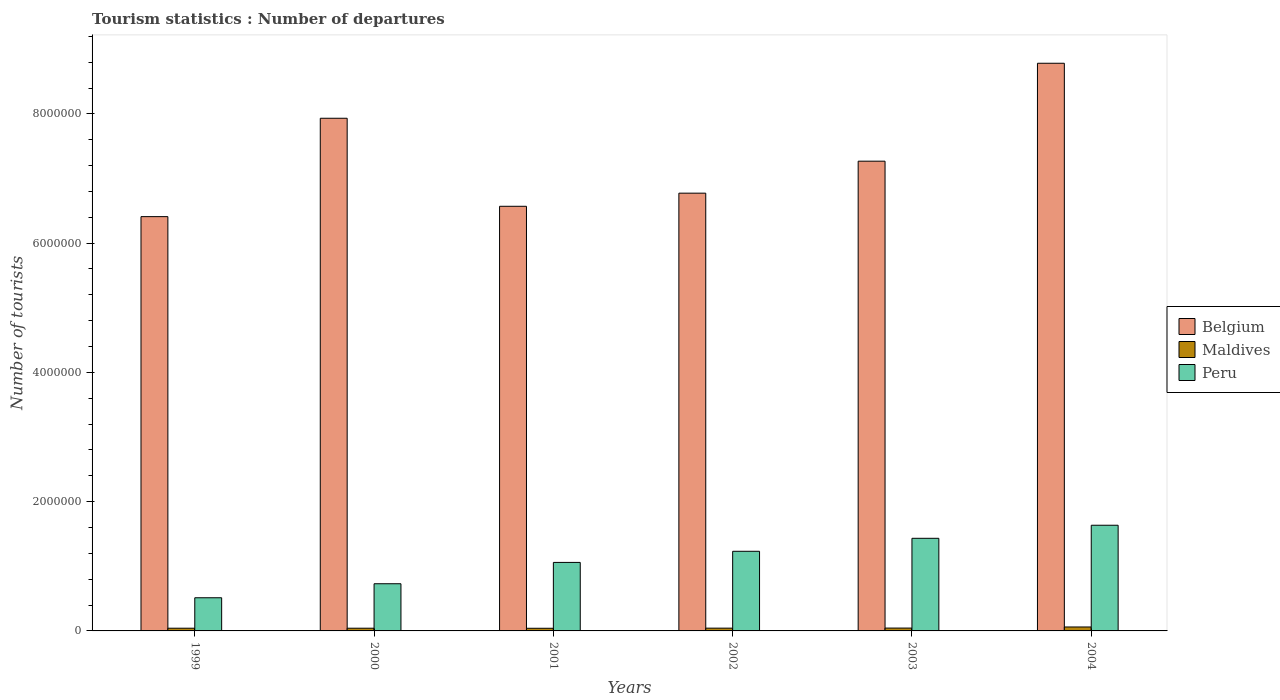Are the number of bars per tick equal to the number of legend labels?
Offer a very short reply. Yes. Are the number of bars on each tick of the X-axis equal?
Offer a terse response. Yes. How many bars are there on the 2nd tick from the right?
Offer a terse response. 3. What is the label of the 6th group of bars from the left?
Keep it short and to the point. 2004. What is the number of tourist departures in Maldives in 1999?
Your answer should be compact. 4.20e+04. Across all years, what is the maximum number of tourist departures in Belgium?
Your answer should be compact. 8.78e+06. Across all years, what is the minimum number of tourist departures in Maldives?
Keep it short and to the point. 4.10e+04. In which year was the number of tourist departures in Belgium minimum?
Provide a short and direct response. 1999. What is the total number of tourist departures in Belgium in the graph?
Provide a succinct answer. 4.37e+07. What is the difference between the number of tourist departures in Peru in 2000 and that in 2003?
Give a very brief answer. -7.03e+05. What is the difference between the number of tourist departures in Peru in 1999 and the number of tourist departures in Belgium in 2004?
Ensure brevity in your answer.  -8.27e+06. What is the average number of tourist departures in Belgium per year?
Offer a terse response. 7.29e+06. In the year 2004, what is the difference between the number of tourist departures in Maldives and number of tourist departures in Belgium?
Offer a very short reply. -8.72e+06. What is the ratio of the number of tourist departures in Belgium in 2001 to that in 2002?
Provide a short and direct response. 0.97. Is the number of tourist departures in Belgium in 1999 less than that in 2000?
Give a very brief answer. Yes. What is the difference between the highest and the second highest number of tourist departures in Peru?
Make the answer very short. 2.02e+05. What is the difference between the highest and the lowest number of tourist departures in Belgium?
Offer a very short reply. 2.37e+06. In how many years, is the number of tourist departures in Peru greater than the average number of tourist departures in Peru taken over all years?
Your response must be concise. 3. What does the 2nd bar from the left in 2002 represents?
Give a very brief answer. Maldives. Is it the case that in every year, the sum of the number of tourist departures in Peru and number of tourist departures in Maldives is greater than the number of tourist departures in Belgium?
Keep it short and to the point. No. How many bars are there?
Offer a very short reply. 18. What is the difference between two consecutive major ticks on the Y-axis?
Provide a succinct answer. 2.00e+06. Are the values on the major ticks of Y-axis written in scientific E-notation?
Your response must be concise. No. Does the graph contain any zero values?
Give a very brief answer. No. Does the graph contain grids?
Ensure brevity in your answer.  No. How are the legend labels stacked?
Make the answer very short. Vertical. What is the title of the graph?
Make the answer very short. Tourism statistics : Number of departures. What is the label or title of the Y-axis?
Ensure brevity in your answer.  Number of tourists. What is the Number of tourists of Belgium in 1999?
Make the answer very short. 6.41e+06. What is the Number of tourists in Maldives in 1999?
Provide a succinct answer. 4.20e+04. What is the Number of tourists of Peru in 1999?
Your answer should be compact. 5.13e+05. What is the Number of tourists in Belgium in 2000?
Offer a terse response. 7.93e+06. What is the Number of tourists of Maldives in 2000?
Ensure brevity in your answer.  4.20e+04. What is the Number of tourists in Peru in 2000?
Provide a short and direct response. 7.30e+05. What is the Number of tourists of Belgium in 2001?
Offer a terse response. 6.57e+06. What is the Number of tourists of Maldives in 2001?
Your answer should be compact. 4.10e+04. What is the Number of tourists in Peru in 2001?
Offer a very short reply. 1.06e+06. What is the Number of tourists in Belgium in 2002?
Make the answer very short. 6.77e+06. What is the Number of tourists in Maldives in 2002?
Your response must be concise. 4.30e+04. What is the Number of tourists of Peru in 2002?
Provide a short and direct response. 1.23e+06. What is the Number of tourists of Belgium in 2003?
Your response must be concise. 7.27e+06. What is the Number of tourists of Maldives in 2003?
Give a very brief answer. 4.40e+04. What is the Number of tourists in Peru in 2003?
Your response must be concise. 1.43e+06. What is the Number of tourists of Belgium in 2004?
Your answer should be compact. 8.78e+06. What is the Number of tourists in Maldives in 2004?
Give a very brief answer. 6.10e+04. What is the Number of tourists of Peru in 2004?
Offer a very short reply. 1.64e+06. Across all years, what is the maximum Number of tourists in Belgium?
Provide a succinct answer. 8.78e+06. Across all years, what is the maximum Number of tourists of Maldives?
Your answer should be very brief. 6.10e+04. Across all years, what is the maximum Number of tourists in Peru?
Your response must be concise. 1.64e+06. Across all years, what is the minimum Number of tourists in Belgium?
Ensure brevity in your answer.  6.41e+06. Across all years, what is the minimum Number of tourists of Maldives?
Your answer should be compact. 4.10e+04. Across all years, what is the minimum Number of tourists of Peru?
Offer a terse response. 5.13e+05. What is the total Number of tourists in Belgium in the graph?
Make the answer very short. 4.37e+07. What is the total Number of tourists in Maldives in the graph?
Offer a terse response. 2.73e+05. What is the total Number of tourists of Peru in the graph?
Your answer should be very brief. 6.60e+06. What is the difference between the Number of tourists in Belgium in 1999 and that in 2000?
Offer a very short reply. -1.52e+06. What is the difference between the Number of tourists in Maldives in 1999 and that in 2000?
Provide a succinct answer. 0. What is the difference between the Number of tourists in Peru in 1999 and that in 2000?
Your answer should be compact. -2.17e+05. What is the difference between the Number of tourists of Maldives in 1999 and that in 2001?
Your answer should be compact. 1000. What is the difference between the Number of tourists in Peru in 1999 and that in 2001?
Make the answer very short. -5.47e+05. What is the difference between the Number of tourists in Belgium in 1999 and that in 2002?
Offer a terse response. -3.63e+05. What is the difference between the Number of tourists in Maldives in 1999 and that in 2002?
Keep it short and to the point. -1000. What is the difference between the Number of tourists in Peru in 1999 and that in 2002?
Provide a short and direct response. -7.19e+05. What is the difference between the Number of tourists in Belgium in 1999 and that in 2003?
Your answer should be very brief. -8.58e+05. What is the difference between the Number of tourists in Maldives in 1999 and that in 2003?
Provide a short and direct response. -2000. What is the difference between the Number of tourists in Peru in 1999 and that in 2003?
Ensure brevity in your answer.  -9.20e+05. What is the difference between the Number of tourists in Belgium in 1999 and that in 2004?
Offer a terse response. -2.37e+06. What is the difference between the Number of tourists in Maldives in 1999 and that in 2004?
Your answer should be very brief. -1.90e+04. What is the difference between the Number of tourists of Peru in 1999 and that in 2004?
Make the answer very short. -1.12e+06. What is the difference between the Number of tourists in Belgium in 2000 and that in 2001?
Give a very brief answer. 1.36e+06. What is the difference between the Number of tourists in Maldives in 2000 and that in 2001?
Provide a short and direct response. 1000. What is the difference between the Number of tourists of Peru in 2000 and that in 2001?
Keep it short and to the point. -3.30e+05. What is the difference between the Number of tourists of Belgium in 2000 and that in 2002?
Offer a very short reply. 1.16e+06. What is the difference between the Number of tourists of Maldives in 2000 and that in 2002?
Provide a succinct answer. -1000. What is the difference between the Number of tourists in Peru in 2000 and that in 2002?
Keep it short and to the point. -5.02e+05. What is the difference between the Number of tourists in Belgium in 2000 and that in 2003?
Offer a very short reply. 6.64e+05. What is the difference between the Number of tourists of Maldives in 2000 and that in 2003?
Offer a very short reply. -2000. What is the difference between the Number of tourists in Peru in 2000 and that in 2003?
Your response must be concise. -7.03e+05. What is the difference between the Number of tourists in Belgium in 2000 and that in 2004?
Make the answer very short. -8.51e+05. What is the difference between the Number of tourists in Maldives in 2000 and that in 2004?
Offer a terse response. -1.90e+04. What is the difference between the Number of tourists in Peru in 2000 and that in 2004?
Offer a terse response. -9.05e+05. What is the difference between the Number of tourists of Belgium in 2001 and that in 2002?
Ensure brevity in your answer.  -2.03e+05. What is the difference between the Number of tourists of Maldives in 2001 and that in 2002?
Offer a very short reply. -2000. What is the difference between the Number of tourists of Peru in 2001 and that in 2002?
Your answer should be compact. -1.72e+05. What is the difference between the Number of tourists of Belgium in 2001 and that in 2003?
Your answer should be compact. -6.98e+05. What is the difference between the Number of tourists in Maldives in 2001 and that in 2003?
Give a very brief answer. -3000. What is the difference between the Number of tourists of Peru in 2001 and that in 2003?
Your answer should be very brief. -3.73e+05. What is the difference between the Number of tourists of Belgium in 2001 and that in 2004?
Provide a succinct answer. -2.21e+06. What is the difference between the Number of tourists of Peru in 2001 and that in 2004?
Keep it short and to the point. -5.75e+05. What is the difference between the Number of tourists of Belgium in 2002 and that in 2003?
Your response must be concise. -4.95e+05. What is the difference between the Number of tourists of Maldives in 2002 and that in 2003?
Your response must be concise. -1000. What is the difference between the Number of tourists in Peru in 2002 and that in 2003?
Ensure brevity in your answer.  -2.01e+05. What is the difference between the Number of tourists in Belgium in 2002 and that in 2004?
Provide a short and direct response. -2.01e+06. What is the difference between the Number of tourists in Maldives in 2002 and that in 2004?
Your response must be concise. -1.80e+04. What is the difference between the Number of tourists of Peru in 2002 and that in 2004?
Provide a succinct answer. -4.03e+05. What is the difference between the Number of tourists of Belgium in 2003 and that in 2004?
Offer a very short reply. -1.52e+06. What is the difference between the Number of tourists of Maldives in 2003 and that in 2004?
Keep it short and to the point. -1.70e+04. What is the difference between the Number of tourists in Peru in 2003 and that in 2004?
Keep it short and to the point. -2.02e+05. What is the difference between the Number of tourists of Belgium in 1999 and the Number of tourists of Maldives in 2000?
Ensure brevity in your answer.  6.37e+06. What is the difference between the Number of tourists of Belgium in 1999 and the Number of tourists of Peru in 2000?
Ensure brevity in your answer.  5.68e+06. What is the difference between the Number of tourists of Maldives in 1999 and the Number of tourists of Peru in 2000?
Your response must be concise. -6.88e+05. What is the difference between the Number of tourists of Belgium in 1999 and the Number of tourists of Maldives in 2001?
Your answer should be compact. 6.37e+06. What is the difference between the Number of tourists in Belgium in 1999 and the Number of tourists in Peru in 2001?
Ensure brevity in your answer.  5.35e+06. What is the difference between the Number of tourists in Maldives in 1999 and the Number of tourists in Peru in 2001?
Provide a short and direct response. -1.02e+06. What is the difference between the Number of tourists of Belgium in 1999 and the Number of tourists of Maldives in 2002?
Make the answer very short. 6.37e+06. What is the difference between the Number of tourists of Belgium in 1999 and the Number of tourists of Peru in 2002?
Give a very brief answer. 5.18e+06. What is the difference between the Number of tourists in Maldives in 1999 and the Number of tourists in Peru in 2002?
Your answer should be very brief. -1.19e+06. What is the difference between the Number of tourists in Belgium in 1999 and the Number of tourists in Maldives in 2003?
Give a very brief answer. 6.37e+06. What is the difference between the Number of tourists of Belgium in 1999 and the Number of tourists of Peru in 2003?
Offer a very short reply. 4.98e+06. What is the difference between the Number of tourists in Maldives in 1999 and the Number of tourists in Peru in 2003?
Your answer should be very brief. -1.39e+06. What is the difference between the Number of tourists of Belgium in 1999 and the Number of tourists of Maldives in 2004?
Offer a very short reply. 6.35e+06. What is the difference between the Number of tourists in Belgium in 1999 and the Number of tourists in Peru in 2004?
Ensure brevity in your answer.  4.78e+06. What is the difference between the Number of tourists in Maldives in 1999 and the Number of tourists in Peru in 2004?
Ensure brevity in your answer.  -1.59e+06. What is the difference between the Number of tourists of Belgium in 2000 and the Number of tourists of Maldives in 2001?
Provide a short and direct response. 7.89e+06. What is the difference between the Number of tourists in Belgium in 2000 and the Number of tourists in Peru in 2001?
Your answer should be very brief. 6.87e+06. What is the difference between the Number of tourists of Maldives in 2000 and the Number of tourists of Peru in 2001?
Your response must be concise. -1.02e+06. What is the difference between the Number of tourists in Belgium in 2000 and the Number of tourists in Maldives in 2002?
Give a very brief answer. 7.89e+06. What is the difference between the Number of tourists in Belgium in 2000 and the Number of tourists in Peru in 2002?
Keep it short and to the point. 6.70e+06. What is the difference between the Number of tourists in Maldives in 2000 and the Number of tourists in Peru in 2002?
Make the answer very short. -1.19e+06. What is the difference between the Number of tourists of Belgium in 2000 and the Number of tourists of Maldives in 2003?
Your answer should be compact. 7.89e+06. What is the difference between the Number of tourists of Belgium in 2000 and the Number of tourists of Peru in 2003?
Ensure brevity in your answer.  6.50e+06. What is the difference between the Number of tourists of Maldives in 2000 and the Number of tourists of Peru in 2003?
Give a very brief answer. -1.39e+06. What is the difference between the Number of tourists of Belgium in 2000 and the Number of tourists of Maldives in 2004?
Ensure brevity in your answer.  7.87e+06. What is the difference between the Number of tourists of Belgium in 2000 and the Number of tourists of Peru in 2004?
Your answer should be very brief. 6.30e+06. What is the difference between the Number of tourists in Maldives in 2000 and the Number of tourists in Peru in 2004?
Your answer should be very brief. -1.59e+06. What is the difference between the Number of tourists of Belgium in 2001 and the Number of tourists of Maldives in 2002?
Make the answer very short. 6.53e+06. What is the difference between the Number of tourists in Belgium in 2001 and the Number of tourists in Peru in 2002?
Give a very brief answer. 5.34e+06. What is the difference between the Number of tourists of Maldives in 2001 and the Number of tourists of Peru in 2002?
Provide a short and direct response. -1.19e+06. What is the difference between the Number of tourists of Belgium in 2001 and the Number of tourists of Maldives in 2003?
Offer a terse response. 6.53e+06. What is the difference between the Number of tourists in Belgium in 2001 and the Number of tourists in Peru in 2003?
Offer a terse response. 5.14e+06. What is the difference between the Number of tourists of Maldives in 2001 and the Number of tourists of Peru in 2003?
Give a very brief answer. -1.39e+06. What is the difference between the Number of tourists in Belgium in 2001 and the Number of tourists in Maldives in 2004?
Ensure brevity in your answer.  6.51e+06. What is the difference between the Number of tourists of Belgium in 2001 and the Number of tourists of Peru in 2004?
Your answer should be compact. 4.94e+06. What is the difference between the Number of tourists of Maldives in 2001 and the Number of tourists of Peru in 2004?
Make the answer very short. -1.59e+06. What is the difference between the Number of tourists in Belgium in 2002 and the Number of tourists in Maldives in 2003?
Give a very brief answer. 6.73e+06. What is the difference between the Number of tourists of Belgium in 2002 and the Number of tourists of Peru in 2003?
Make the answer very short. 5.34e+06. What is the difference between the Number of tourists of Maldives in 2002 and the Number of tourists of Peru in 2003?
Ensure brevity in your answer.  -1.39e+06. What is the difference between the Number of tourists in Belgium in 2002 and the Number of tourists in Maldives in 2004?
Offer a terse response. 6.71e+06. What is the difference between the Number of tourists of Belgium in 2002 and the Number of tourists of Peru in 2004?
Offer a terse response. 5.14e+06. What is the difference between the Number of tourists in Maldives in 2002 and the Number of tourists in Peru in 2004?
Offer a very short reply. -1.59e+06. What is the difference between the Number of tourists of Belgium in 2003 and the Number of tourists of Maldives in 2004?
Your answer should be compact. 7.21e+06. What is the difference between the Number of tourists of Belgium in 2003 and the Number of tourists of Peru in 2004?
Offer a terse response. 5.63e+06. What is the difference between the Number of tourists in Maldives in 2003 and the Number of tourists in Peru in 2004?
Your answer should be very brief. -1.59e+06. What is the average Number of tourists in Belgium per year?
Provide a short and direct response. 7.29e+06. What is the average Number of tourists in Maldives per year?
Offer a very short reply. 4.55e+04. What is the average Number of tourists of Peru per year?
Your answer should be compact. 1.10e+06. In the year 1999, what is the difference between the Number of tourists of Belgium and Number of tourists of Maldives?
Keep it short and to the point. 6.37e+06. In the year 1999, what is the difference between the Number of tourists in Belgium and Number of tourists in Peru?
Make the answer very short. 5.90e+06. In the year 1999, what is the difference between the Number of tourists in Maldives and Number of tourists in Peru?
Your answer should be compact. -4.71e+05. In the year 2000, what is the difference between the Number of tourists in Belgium and Number of tourists in Maldives?
Keep it short and to the point. 7.89e+06. In the year 2000, what is the difference between the Number of tourists of Belgium and Number of tourists of Peru?
Your answer should be compact. 7.20e+06. In the year 2000, what is the difference between the Number of tourists in Maldives and Number of tourists in Peru?
Provide a short and direct response. -6.88e+05. In the year 2001, what is the difference between the Number of tourists of Belgium and Number of tourists of Maldives?
Provide a short and direct response. 6.53e+06. In the year 2001, what is the difference between the Number of tourists in Belgium and Number of tourists in Peru?
Keep it short and to the point. 5.51e+06. In the year 2001, what is the difference between the Number of tourists in Maldives and Number of tourists in Peru?
Ensure brevity in your answer.  -1.02e+06. In the year 2002, what is the difference between the Number of tourists of Belgium and Number of tourists of Maldives?
Provide a short and direct response. 6.73e+06. In the year 2002, what is the difference between the Number of tourists in Belgium and Number of tourists in Peru?
Your answer should be compact. 5.54e+06. In the year 2002, what is the difference between the Number of tourists in Maldives and Number of tourists in Peru?
Ensure brevity in your answer.  -1.19e+06. In the year 2003, what is the difference between the Number of tourists of Belgium and Number of tourists of Maldives?
Give a very brief answer. 7.22e+06. In the year 2003, what is the difference between the Number of tourists in Belgium and Number of tourists in Peru?
Your response must be concise. 5.84e+06. In the year 2003, what is the difference between the Number of tourists in Maldives and Number of tourists in Peru?
Offer a terse response. -1.39e+06. In the year 2004, what is the difference between the Number of tourists in Belgium and Number of tourists in Maldives?
Keep it short and to the point. 8.72e+06. In the year 2004, what is the difference between the Number of tourists of Belgium and Number of tourists of Peru?
Give a very brief answer. 7.15e+06. In the year 2004, what is the difference between the Number of tourists in Maldives and Number of tourists in Peru?
Provide a succinct answer. -1.57e+06. What is the ratio of the Number of tourists of Belgium in 1999 to that in 2000?
Provide a succinct answer. 0.81. What is the ratio of the Number of tourists in Peru in 1999 to that in 2000?
Ensure brevity in your answer.  0.7. What is the ratio of the Number of tourists of Belgium in 1999 to that in 2001?
Provide a succinct answer. 0.98. What is the ratio of the Number of tourists of Maldives in 1999 to that in 2001?
Your answer should be compact. 1.02. What is the ratio of the Number of tourists in Peru in 1999 to that in 2001?
Give a very brief answer. 0.48. What is the ratio of the Number of tourists in Belgium in 1999 to that in 2002?
Your answer should be compact. 0.95. What is the ratio of the Number of tourists in Maldives in 1999 to that in 2002?
Provide a short and direct response. 0.98. What is the ratio of the Number of tourists in Peru in 1999 to that in 2002?
Offer a terse response. 0.42. What is the ratio of the Number of tourists in Belgium in 1999 to that in 2003?
Make the answer very short. 0.88. What is the ratio of the Number of tourists in Maldives in 1999 to that in 2003?
Make the answer very short. 0.95. What is the ratio of the Number of tourists of Peru in 1999 to that in 2003?
Keep it short and to the point. 0.36. What is the ratio of the Number of tourists of Belgium in 1999 to that in 2004?
Give a very brief answer. 0.73. What is the ratio of the Number of tourists in Maldives in 1999 to that in 2004?
Make the answer very short. 0.69. What is the ratio of the Number of tourists in Peru in 1999 to that in 2004?
Make the answer very short. 0.31. What is the ratio of the Number of tourists of Belgium in 2000 to that in 2001?
Provide a succinct answer. 1.21. What is the ratio of the Number of tourists of Maldives in 2000 to that in 2001?
Ensure brevity in your answer.  1.02. What is the ratio of the Number of tourists of Peru in 2000 to that in 2001?
Provide a succinct answer. 0.69. What is the ratio of the Number of tourists of Belgium in 2000 to that in 2002?
Your answer should be compact. 1.17. What is the ratio of the Number of tourists in Maldives in 2000 to that in 2002?
Ensure brevity in your answer.  0.98. What is the ratio of the Number of tourists in Peru in 2000 to that in 2002?
Provide a short and direct response. 0.59. What is the ratio of the Number of tourists of Belgium in 2000 to that in 2003?
Give a very brief answer. 1.09. What is the ratio of the Number of tourists in Maldives in 2000 to that in 2003?
Keep it short and to the point. 0.95. What is the ratio of the Number of tourists of Peru in 2000 to that in 2003?
Ensure brevity in your answer.  0.51. What is the ratio of the Number of tourists in Belgium in 2000 to that in 2004?
Make the answer very short. 0.9. What is the ratio of the Number of tourists of Maldives in 2000 to that in 2004?
Your response must be concise. 0.69. What is the ratio of the Number of tourists in Peru in 2000 to that in 2004?
Your response must be concise. 0.45. What is the ratio of the Number of tourists of Maldives in 2001 to that in 2002?
Your response must be concise. 0.95. What is the ratio of the Number of tourists of Peru in 2001 to that in 2002?
Ensure brevity in your answer.  0.86. What is the ratio of the Number of tourists of Belgium in 2001 to that in 2003?
Give a very brief answer. 0.9. What is the ratio of the Number of tourists in Maldives in 2001 to that in 2003?
Provide a short and direct response. 0.93. What is the ratio of the Number of tourists in Peru in 2001 to that in 2003?
Ensure brevity in your answer.  0.74. What is the ratio of the Number of tourists in Belgium in 2001 to that in 2004?
Your answer should be compact. 0.75. What is the ratio of the Number of tourists in Maldives in 2001 to that in 2004?
Ensure brevity in your answer.  0.67. What is the ratio of the Number of tourists in Peru in 2001 to that in 2004?
Provide a succinct answer. 0.65. What is the ratio of the Number of tourists in Belgium in 2002 to that in 2003?
Your response must be concise. 0.93. What is the ratio of the Number of tourists of Maldives in 2002 to that in 2003?
Provide a short and direct response. 0.98. What is the ratio of the Number of tourists in Peru in 2002 to that in 2003?
Provide a succinct answer. 0.86. What is the ratio of the Number of tourists of Belgium in 2002 to that in 2004?
Your response must be concise. 0.77. What is the ratio of the Number of tourists of Maldives in 2002 to that in 2004?
Provide a short and direct response. 0.7. What is the ratio of the Number of tourists of Peru in 2002 to that in 2004?
Your response must be concise. 0.75. What is the ratio of the Number of tourists in Belgium in 2003 to that in 2004?
Provide a succinct answer. 0.83. What is the ratio of the Number of tourists of Maldives in 2003 to that in 2004?
Make the answer very short. 0.72. What is the ratio of the Number of tourists in Peru in 2003 to that in 2004?
Your answer should be compact. 0.88. What is the difference between the highest and the second highest Number of tourists of Belgium?
Ensure brevity in your answer.  8.51e+05. What is the difference between the highest and the second highest Number of tourists of Maldives?
Provide a short and direct response. 1.70e+04. What is the difference between the highest and the second highest Number of tourists of Peru?
Give a very brief answer. 2.02e+05. What is the difference between the highest and the lowest Number of tourists in Belgium?
Your answer should be very brief. 2.37e+06. What is the difference between the highest and the lowest Number of tourists of Maldives?
Make the answer very short. 2.00e+04. What is the difference between the highest and the lowest Number of tourists of Peru?
Keep it short and to the point. 1.12e+06. 